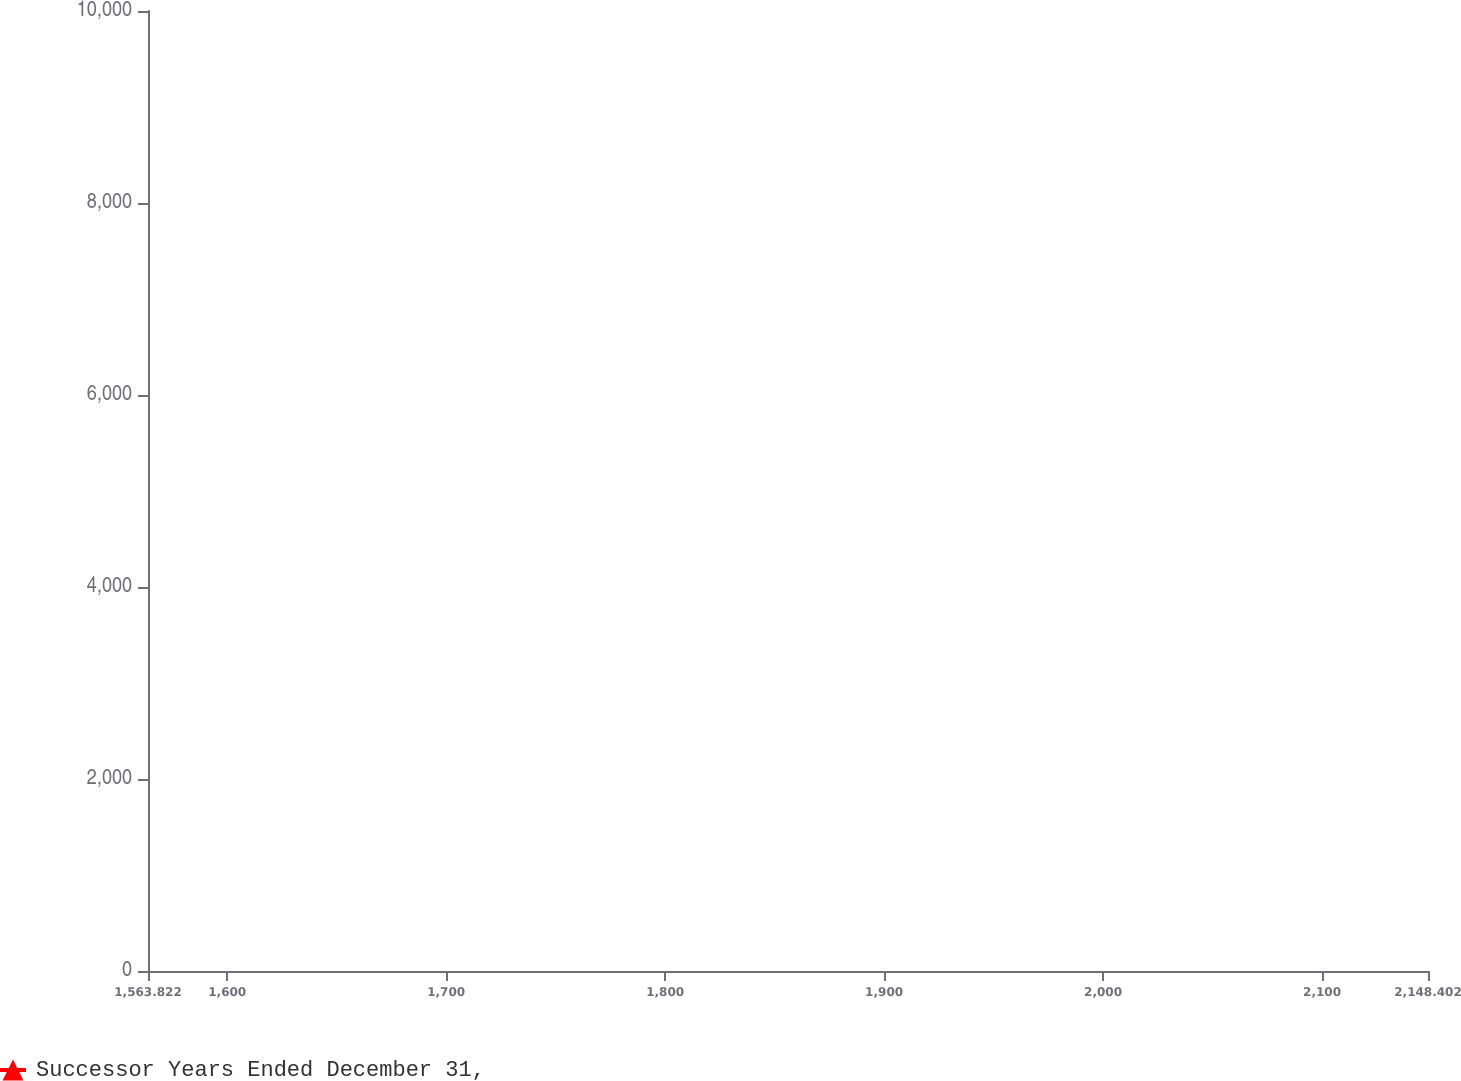Convert chart to OTSL. <chart><loc_0><loc_0><loc_500><loc_500><line_chart><ecel><fcel>Successor Years Ended December 31,<nl><fcel>1622.28<fcel>8730.51<nl><fcel>1730.15<fcel>8969.79<nl><fcel>1788.61<fcel>7418.82<nl><fcel>2038.28<fcel>6759.04<nl><fcel>2206.86<fcel>9203.23<nl></chart> 